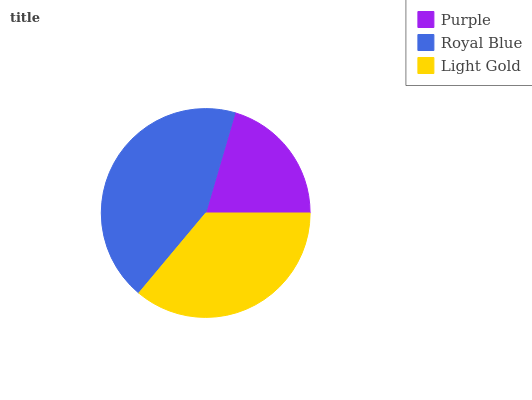Is Purple the minimum?
Answer yes or no. Yes. Is Royal Blue the maximum?
Answer yes or no. Yes. Is Light Gold the minimum?
Answer yes or no. No. Is Light Gold the maximum?
Answer yes or no. No. Is Royal Blue greater than Light Gold?
Answer yes or no. Yes. Is Light Gold less than Royal Blue?
Answer yes or no. Yes. Is Light Gold greater than Royal Blue?
Answer yes or no. No. Is Royal Blue less than Light Gold?
Answer yes or no. No. Is Light Gold the high median?
Answer yes or no. Yes. Is Light Gold the low median?
Answer yes or no. Yes. Is Purple the high median?
Answer yes or no. No. Is Purple the low median?
Answer yes or no. No. 